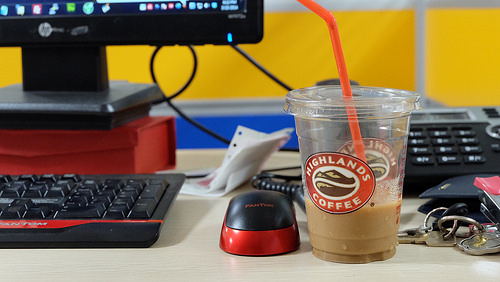<image>
Is there a phone behind the coffee? Yes. From this viewpoint, the phone is positioned behind the coffee, with the coffee partially or fully occluding the phone. 